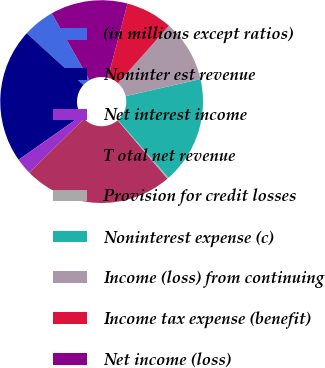Convert chart to OTSL. <chart><loc_0><loc_0><loc_500><loc_500><pie_chart><fcel>(in millions except ratios)<fcel>Noninter est revenue<fcel>Net interest income<fcel>T otal net revenue<fcel>Provision for credit losses<fcel>Noninterest expense (c)<fcel>Income (loss) from continuing<fcel>Income tax expense (benefit)<fcel>Net income (loss)<nl><fcel>5.05%<fcel>21.49%<fcel>2.63%<fcel>23.9%<fcel>0.22%<fcel>17.1%<fcel>9.87%<fcel>7.46%<fcel>12.28%<nl></chart> 